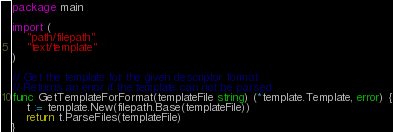<code> <loc_0><loc_0><loc_500><loc_500><_Go_>package main

import (
	"path/filepath"
	"text/template"
)

// Get the template for the given descriptor format
// Returns an error if the template can not be parsed
func GetTemplateForFormat(templateFile string) (*template.Template, error) {
	t := template.New(filepath.Base(templateFile))
	return t.ParseFiles(templateFile)
}
</code> 